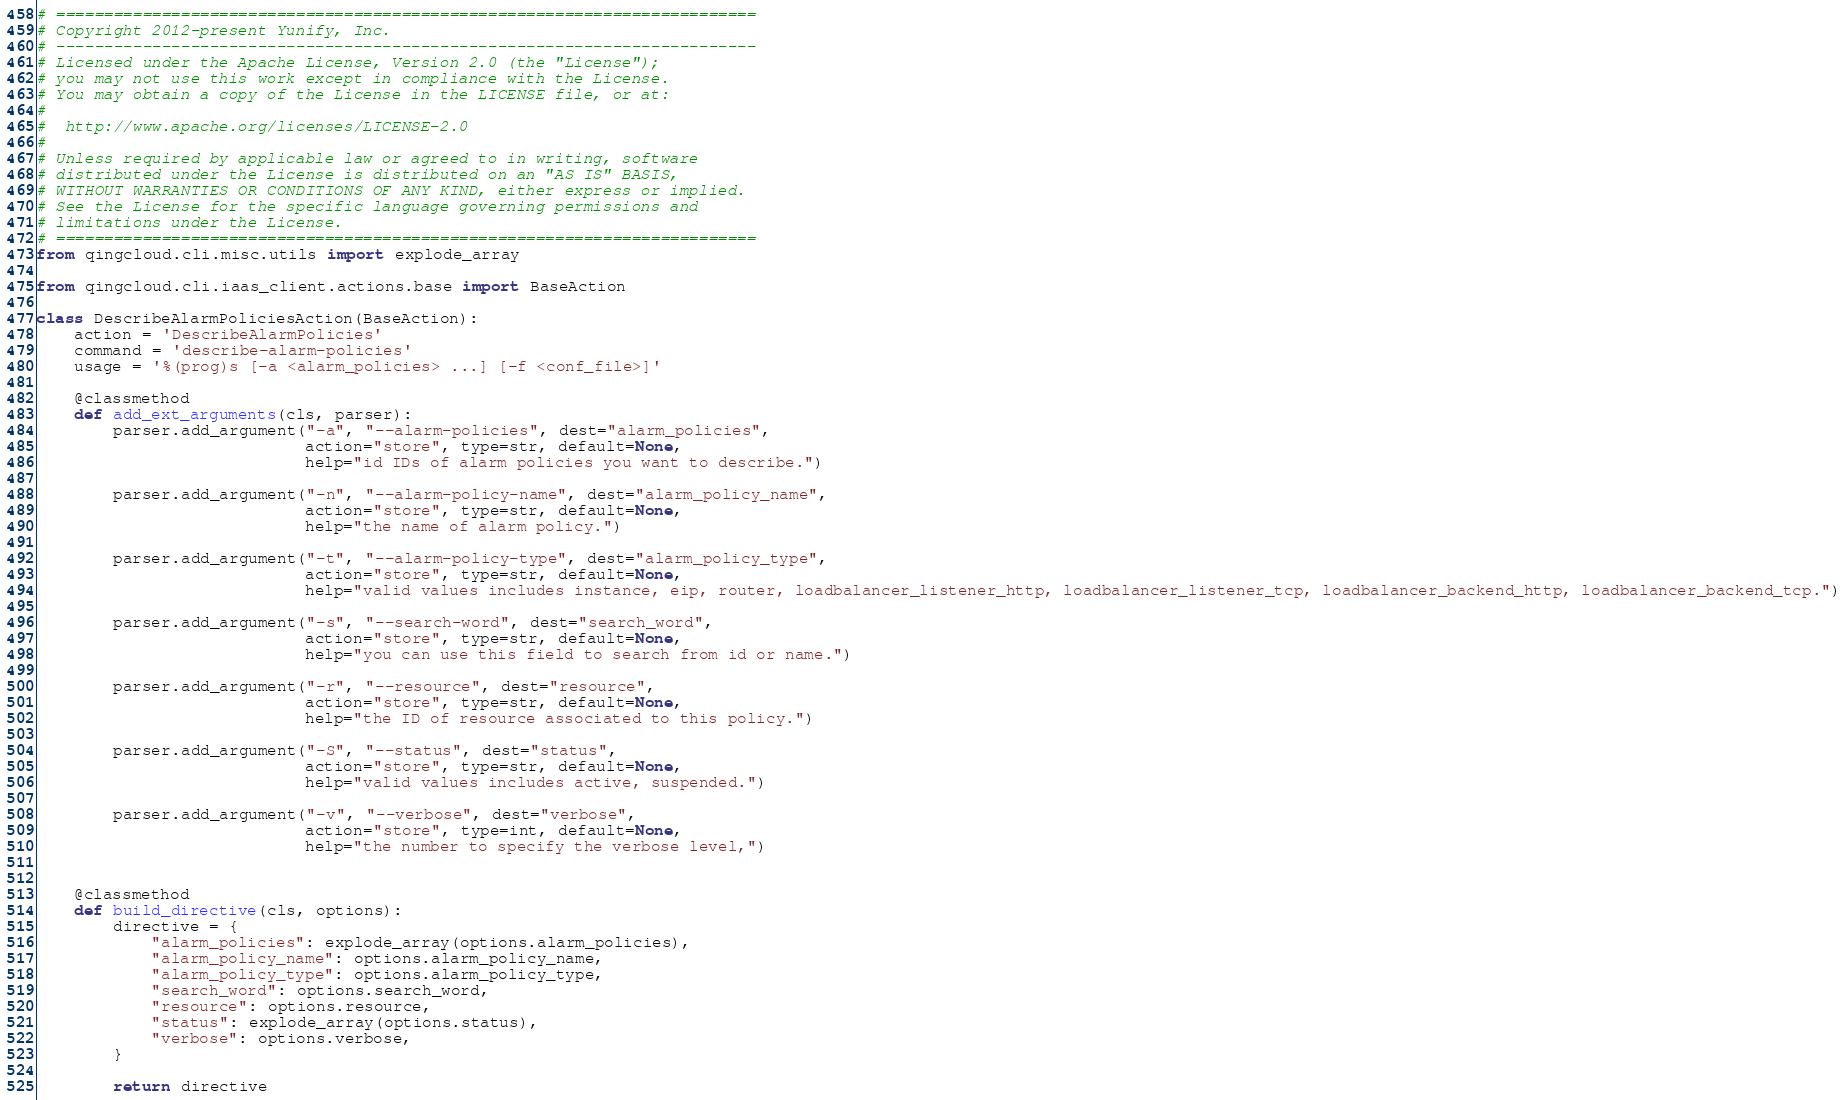<code> <loc_0><loc_0><loc_500><loc_500><_Python_># =========================================================================
# Copyright 2012-present Yunify, Inc.
# -------------------------------------------------------------------------
# Licensed under the Apache License, Version 2.0 (the "License");
# you may not use this work except in compliance with the License.
# You may obtain a copy of the License in the LICENSE file, or at:
#
#  http://www.apache.org/licenses/LICENSE-2.0
#
# Unless required by applicable law or agreed to in writing, software
# distributed under the License is distributed on an "AS IS" BASIS,
# WITHOUT WARRANTIES OR CONDITIONS OF ANY KIND, either express or implied.
# See the License for the specific language governing permissions and
# limitations under the License.
# =========================================================================
from qingcloud.cli.misc.utils import explode_array

from qingcloud.cli.iaas_client.actions.base import BaseAction

class DescribeAlarmPoliciesAction(BaseAction):
    action = 'DescribeAlarmPolicies'
    command = 'describe-alarm-policies'
    usage = '%(prog)s [-a <alarm_policies> ...] [-f <conf_file>]'

    @classmethod
    def add_ext_arguments(cls, parser):
        parser.add_argument("-a", "--alarm-policies", dest="alarm_policies",
                            action="store", type=str, default=None,
                            help="id IDs of alarm policies you want to describe.")

        parser.add_argument("-n", "--alarm-policy-name", dest="alarm_policy_name",
                            action="store", type=str, default=None,
                            help="the name of alarm policy.")

        parser.add_argument("-t", "--alarm-policy-type", dest="alarm_policy_type",
                            action="store", type=str, default=None,
                            help="valid values includes instance, eip, router, loadbalancer_listener_http, loadbalancer_listener_tcp, loadbalancer_backend_http, loadbalancer_backend_tcp.")

        parser.add_argument("-s", "--search-word", dest="search_word",
                            action="store", type=str, default=None,
                            help="you can use this field to search from id or name.")

        parser.add_argument("-r", "--resource", dest="resource",
                            action="store", type=str, default=None,
                            help="the ID of resource associated to this policy.")

        parser.add_argument("-S", "--status", dest="status",
                            action="store", type=str, default=None,
                            help="valid values includes active, suspended.")

        parser.add_argument("-v", "--verbose", dest="verbose",
                            action="store", type=int, default=None,
                            help="the number to specify the verbose level,")


    @classmethod
    def build_directive(cls, options):
        directive = {
            "alarm_policies": explode_array(options.alarm_policies),
            "alarm_policy_name": options.alarm_policy_name,
            "alarm_policy_type": options.alarm_policy_type,
            "search_word": options.search_word,
            "resource": options.resource,
            "status": explode_array(options.status),
            "verbose": options.verbose,
        }
        
        return directive
</code> 